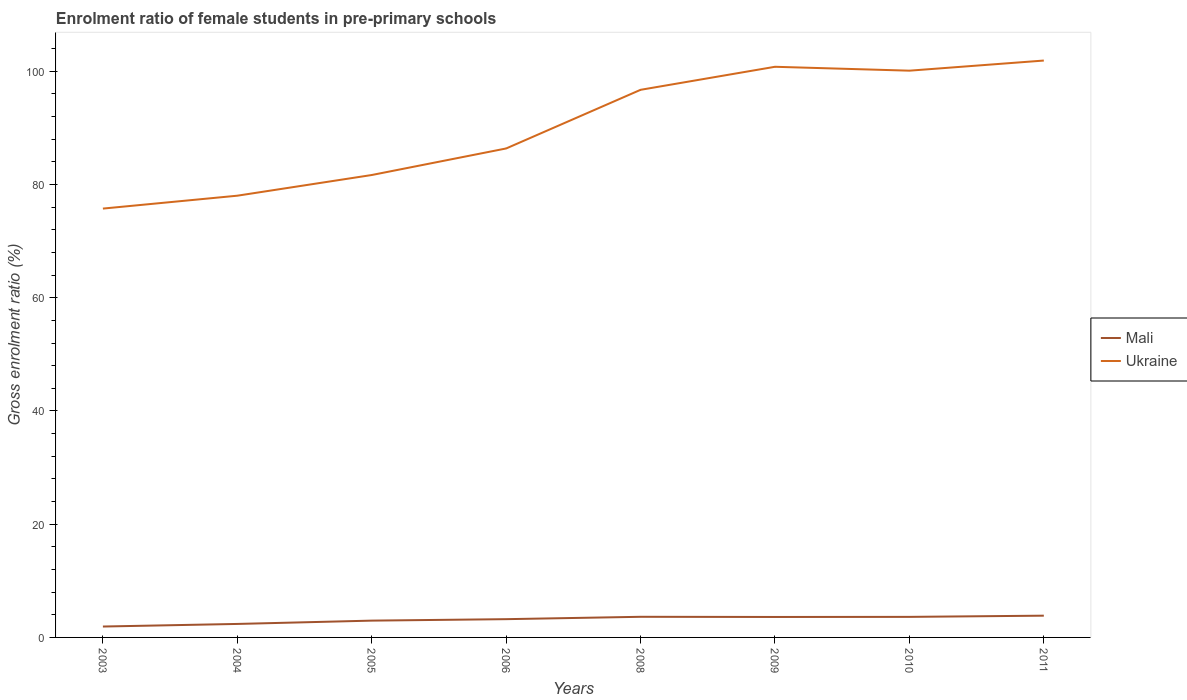How many different coloured lines are there?
Your answer should be compact. 2. Is the number of lines equal to the number of legend labels?
Give a very brief answer. Yes. Across all years, what is the maximum enrolment ratio of female students in pre-primary schools in Ukraine?
Keep it short and to the point. 75.74. What is the total enrolment ratio of female students in pre-primary schools in Ukraine in the graph?
Offer a very short reply. -15.05. What is the difference between the highest and the second highest enrolment ratio of female students in pre-primary schools in Mali?
Keep it short and to the point. 1.92. What is the difference between the highest and the lowest enrolment ratio of female students in pre-primary schools in Ukraine?
Offer a terse response. 4. Is the enrolment ratio of female students in pre-primary schools in Mali strictly greater than the enrolment ratio of female students in pre-primary schools in Ukraine over the years?
Offer a very short reply. Yes. How many years are there in the graph?
Offer a very short reply. 8. What is the difference between two consecutive major ticks on the Y-axis?
Your answer should be compact. 20. Does the graph contain grids?
Your response must be concise. No. Where does the legend appear in the graph?
Provide a short and direct response. Center right. How many legend labels are there?
Offer a very short reply. 2. What is the title of the graph?
Provide a short and direct response. Enrolment ratio of female students in pre-primary schools. Does "Fragile and conflict affected situations" appear as one of the legend labels in the graph?
Your response must be concise. No. What is the label or title of the X-axis?
Your answer should be compact. Years. What is the Gross enrolment ratio (%) in Mali in 2003?
Make the answer very short. 1.92. What is the Gross enrolment ratio (%) in Ukraine in 2003?
Provide a short and direct response. 75.74. What is the Gross enrolment ratio (%) of Mali in 2004?
Provide a succinct answer. 2.38. What is the Gross enrolment ratio (%) in Ukraine in 2004?
Provide a succinct answer. 78.02. What is the Gross enrolment ratio (%) of Mali in 2005?
Keep it short and to the point. 2.97. What is the Gross enrolment ratio (%) of Ukraine in 2005?
Provide a succinct answer. 81.67. What is the Gross enrolment ratio (%) in Mali in 2006?
Your response must be concise. 3.23. What is the Gross enrolment ratio (%) of Ukraine in 2006?
Make the answer very short. 86.36. What is the Gross enrolment ratio (%) of Mali in 2008?
Give a very brief answer. 3.64. What is the Gross enrolment ratio (%) of Ukraine in 2008?
Your answer should be very brief. 96.72. What is the Gross enrolment ratio (%) of Mali in 2009?
Provide a succinct answer. 3.61. What is the Gross enrolment ratio (%) in Ukraine in 2009?
Offer a terse response. 100.79. What is the Gross enrolment ratio (%) in Mali in 2010?
Your answer should be very brief. 3.63. What is the Gross enrolment ratio (%) of Ukraine in 2010?
Give a very brief answer. 100.1. What is the Gross enrolment ratio (%) of Mali in 2011?
Keep it short and to the point. 3.84. What is the Gross enrolment ratio (%) of Ukraine in 2011?
Offer a terse response. 101.89. Across all years, what is the maximum Gross enrolment ratio (%) in Mali?
Provide a succinct answer. 3.84. Across all years, what is the maximum Gross enrolment ratio (%) in Ukraine?
Offer a very short reply. 101.89. Across all years, what is the minimum Gross enrolment ratio (%) in Mali?
Provide a succinct answer. 1.92. Across all years, what is the minimum Gross enrolment ratio (%) in Ukraine?
Offer a terse response. 75.74. What is the total Gross enrolment ratio (%) in Mali in the graph?
Provide a short and direct response. 25.23. What is the total Gross enrolment ratio (%) of Ukraine in the graph?
Offer a terse response. 721.29. What is the difference between the Gross enrolment ratio (%) of Mali in 2003 and that in 2004?
Your answer should be compact. -0.46. What is the difference between the Gross enrolment ratio (%) of Ukraine in 2003 and that in 2004?
Provide a succinct answer. -2.28. What is the difference between the Gross enrolment ratio (%) in Mali in 2003 and that in 2005?
Give a very brief answer. -1.04. What is the difference between the Gross enrolment ratio (%) in Ukraine in 2003 and that in 2005?
Your answer should be very brief. -5.93. What is the difference between the Gross enrolment ratio (%) in Mali in 2003 and that in 2006?
Your answer should be very brief. -1.3. What is the difference between the Gross enrolment ratio (%) of Ukraine in 2003 and that in 2006?
Provide a short and direct response. -10.62. What is the difference between the Gross enrolment ratio (%) of Mali in 2003 and that in 2008?
Give a very brief answer. -1.72. What is the difference between the Gross enrolment ratio (%) of Ukraine in 2003 and that in 2008?
Provide a short and direct response. -20.98. What is the difference between the Gross enrolment ratio (%) of Mali in 2003 and that in 2009?
Offer a very short reply. -1.69. What is the difference between the Gross enrolment ratio (%) in Ukraine in 2003 and that in 2009?
Keep it short and to the point. -25.05. What is the difference between the Gross enrolment ratio (%) of Mali in 2003 and that in 2010?
Provide a short and direct response. -1.7. What is the difference between the Gross enrolment ratio (%) of Ukraine in 2003 and that in 2010?
Your answer should be compact. -24.36. What is the difference between the Gross enrolment ratio (%) of Mali in 2003 and that in 2011?
Offer a terse response. -1.92. What is the difference between the Gross enrolment ratio (%) in Ukraine in 2003 and that in 2011?
Provide a short and direct response. -26.15. What is the difference between the Gross enrolment ratio (%) of Mali in 2004 and that in 2005?
Make the answer very short. -0.58. What is the difference between the Gross enrolment ratio (%) of Ukraine in 2004 and that in 2005?
Your answer should be very brief. -3.65. What is the difference between the Gross enrolment ratio (%) in Mali in 2004 and that in 2006?
Offer a very short reply. -0.84. What is the difference between the Gross enrolment ratio (%) of Ukraine in 2004 and that in 2006?
Offer a terse response. -8.34. What is the difference between the Gross enrolment ratio (%) in Mali in 2004 and that in 2008?
Offer a terse response. -1.26. What is the difference between the Gross enrolment ratio (%) in Ukraine in 2004 and that in 2008?
Your answer should be very brief. -18.7. What is the difference between the Gross enrolment ratio (%) of Mali in 2004 and that in 2009?
Make the answer very short. -1.23. What is the difference between the Gross enrolment ratio (%) of Ukraine in 2004 and that in 2009?
Give a very brief answer. -22.77. What is the difference between the Gross enrolment ratio (%) in Mali in 2004 and that in 2010?
Provide a succinct answer. -1.25. What is the difference between the Gross enrolment ratio (%) of Ukraine in 2004 and that in 2010?
Your answer should be compact. -22.08. What is the difference between the Gross enrolment ratio (%) in Mali in 2004 and that in 2011?
Your answer should be compact. -1.46. What is the difference between the Gross enrolment ratio (%) in Ukraine in 2004 and that in 2011?
Provide a succinct answer. -23.87. What is the difference between the Gross enrolment ratio (%) in Mali in 2005 and that in 2006?
Offer a very short reply. -0.26. What is the difference between the Gross enrolment ratio (%) in Ukraine in 2005 and that in 2006?
Make the answer very short. -4.69. What is the difference between the Gross enrolment ratio (%) of Mali in 2005 and that in 2008?
Your answer should be compact. -0.68. What is the difference between the Gross enrolment ratio (%) in Ukraine in 2005 and that in 2008?
Ensure brevity in your answer.  -15.05. What is the difference between the Gross enrolment ratio (%) of Mali in 2005 and that in 2009?
Your answer should be compact. -0.65. What is the difference between the Gross enrolment ratio (%) in Ukraine in 2005 and that in 2009?
Your answer should be very brief. -19.12. What is the difference between the Gross enrolment ratio (%) of Mali in 2005 and that in 2010?
Keep it short and to the point. -0.66. What is the difference between the Gross enrolment ratio (%) in Ukraine in 2005 and that in 2010?
Your answer should be very brief. -18.43. What is the difference between the Gross enrolment ratio (%) of Mali in 2005 and that in 2011?
Ensure brevity in your answer.  -0.88. What is the difference between the Gross enrolment ratio (%) of Ukraine in 2005 and that in 2011?
Keep it short and to the point. -20.22. What is the difference between the Gross enrolment ratio (%) in Mali in 2006 and that in 2008?
Ensure brevity in your answer.  -0.42. What is the difference between the Gross enrolment ratio (%) in Ukraine in 2006 and that in 2008?
Provide a succinct answer. -10.36. What is the difference between the Gross enrolment ratio (%) in Mali in 2006 and that in 2009?
Give a very brief answer. -0.39. What is the difference between the Gross enrolment ratio (%) in Ukraine in 2006 and that in 2009?
Your answer should be compact. -14.43. What is the difference between the Gross enrolment ratio (%) in Mali in 2006 and that in 2010?
Make the answer very short. -0.4. What is the difference between the Gross enrolment ratio (%) of Ukraine in 2006 and that in 2010?
Your answer should be very brief. -13.74. What is the difference between the Gross enrolment ratio (%) of Mali in 2006 and that in 2011?
Your answer should be compact. -0.62. What is the difference between the Gross enrolment ratio (%) in Ukraine in 2006 and that in 2011?
Give a very brief answer. -15.53. What is the difference between the Gross enrolment ratio (%) of Mali in 2008 and that in 2009?
Your answer should be very brief. 0.03. What is the difference between the Gross enrolment ratio (%) in Ukraine in 2008 and that in 2009?
Offer a very short reply. -4.07. What is the difference between the Gross enrolment ratio (%) of Mali in 2008 and that in 2010?
Offer a very short reply. 0.02. What is the difference between the Gross enrolment ratio (%) of Ukraine in 2008 and that in 2010?
Ensure brevity in your answer.  -3.38. What is the difference between the Gross enrolment ratio (%) in Mali in 2008 and that in 2011?
Give a very brief answer. -0.2. What is the difference between the Gross enrolment ratio (%) of Ukraine in 2008 and that in 2011?
Give a very brief answer. -5.17. What is the difference between the Gross enrolment ratio (%) of Mali in 2009 and that in 2010?
Offer a terse response. -0.01. What is the difference between the Gross enrolment ratio (%) in Ukraine in 2009 and that in 2010?
Keep it short and to the point. 0.69. What is the difference between the Gross enrolment ratio (%) of Mali in 2009 and that in 2011?
Your answer should be compact. -0.23. What is the difference between the Gross enrolment ratio (%) of Ukraine in 2009 and that in 2011?
Offer a terse response. -1.1. What is the difference between the Gross enrolment ratio (%) of Mali in 2010 and that in 2011?
Make the answer very short. -0.21. What is the difference between the Gross enrolment ratio (%) in Ukraine in 2010 and that in 2011?
Offer a terse response. -1.79. What is the difference between the Gross enrolment ratio (%) in Mali in 2003 and the Gross enrolment ratio (%) in Ukraine in 2004?
Offer a very short reply. -76.09. What is the difference between the Gross enrolment ratio (%) in Mali in 2003 and the Gross enrolment ratio (%) in Ukraine in 2005?
Give a very brief answer. -79.75. What is the difference between the Gross enrolment ratio (%) of Mali in 2003 and the Gross enrolment ratio (%) of Ukraine in 2006?
Your response must be concise. -84.44. What is the difference between the Gross enrolment ratio (%) in Mali in 2003 and the Gross enrolment ratio (%) in Ukraine in 2008?
Give a very brief answer. -94.8. What is the difference between the Gross enrolment ratio (%) in Mali in 2003 and the Gross enrolment ratio (%) in Ukraine in 2009?
Provide a succinct answer. -98.86. What is the difference between the Gross enrolment ratio (%) of Mali in 2003 and the Gross enrolment ratio (%) of Ukraine in 2010?
Your answer should be very brief. -98.17. What is the difference between the Gross enrolment ratio (%) in Mali in 2003 and the Gross enrolment ratio (%) in Ukraine in 2011?
Provide a short and direct response. -99.96. What is the difference between the Gross enrolment ratio (%) of Mali in 2004 and the Gross enrolment ratio (%) of Ukraine in 2005?
Your answer should be very brief. -79.29. What is the difference between the Gross enrolment ratio (%) in Mali in 2004 and the Gross enrolment ratio (%) in Ukraine in 2006?
Offer a very short reply. -83.98. What is the difference between the Gross enrolment ratio (%) in Mali in 2004 and the Gross enrolment ratio (%) in Ukraine in 2008?
Your response must be concise. -94.34. What is the difference between the Gross enrolment ratio (%) of Mali in 2004 and the Gross enrolment ratio (%) of Ukraine in 2009?
Offer a terse response. -98.4. What is the difference between the Gross enrolment ratio (%) of Mali in 2004 and the Gross enrolment ratio (%) of Ukraine in 2010?
Provide a succinct answer. -97.72. What is the difference between the Gross enrolment ratio (%) of Mali in 2004 and the Gross enrolment ratio (%) of Ukraine in 2011?
Make the answer very short. -99.51. What is the difference between the Gross enrolment ratio (%) in Mali in 2005 and the Gross enrolment ratio (%) in Ukraine in 2006?
Provide a succinct answer. -83.39. What is the difference between the Gross enrolment ratio (%) of Mali in 2005 and the Gross enrolment ratio (%) of Ukraine in 2008?
Give a very brief answer. -93.75. What is the difference between the Gross enrolment ratio (%) in Mali in 2005 and the Gross enrolment ratio (%) in Ukraine in 2009?
Provide a short and direct response. -97.82. What is the difference between the Gross enrolment ratio (%) of Mali in 2005 and the Gross enrolment ratio (%) of Ukraine in 2010?
Provide a short and direct response. -97.13. What is the difference between the Gross enrolment ratio (%) of Mali in 2005 and the Gross enrolment ratio (%) of Ukraine in 2011?
Offer a terse response. -98.92. What is the difference between the Gross enrolment ratio (%) of Mali in 2006 and the Gross enrolment ratio (%) of Ukraine in 2008?
Make the answer very short. -93.49. What is the difference between the Gross enrolment ratio (%) of Mali in 2006 and the Gross enrolment ratio (%) of Ukraine in 2009?
Provide a short and direct response. -97.56. What is the difference between the Gross enrolment ratio (%) of Mali in 2006 and the Gross enrolment ratio (%) of Ukraine in 2010?
Make the answer very short. -96.87. What is the difference between the Gross enrolment ratio (%) in Mali in 2006 and the Gross enrolment ratio (%) in Ukraine in 2011?
Ensure brevity in your answer.  -98.66. What is the difference between the Gross enrolment ratio (%) in Mali in 2008 and the Gross enrolment ratio (%) in Ukraine in 2009?
Provide a succinct answer. -97.14. What is the difference between the Gross enrolment ratio (%) of Mali in 2008 and the Gross enrolment ratio (%) of Ukraine in 2010?
Offer a terse response. -96.45. What is the difference between the Gross enrolment ratio (%) of Mali in 2008 and the Gross enrolment ratio (%) of Ukraine in 2011?
Your response must be concise. -98.24. What is the difference between the Gross enrolment ratio (%) of Mali in 2009 and the Gross enrolment ratio (%) of Ukraine in 2010?
Your answer should be compact. -96.48. What is the difference between the Gross enrolment ratio (%) in Mali in 2009 and the Gross enrolment ratio (%) in Ukraine in 2011?
Make the answer very short. -98.27. What is the difference between the Gross enrolment ratio (%) in Mali in 2010 and the Gross enrolment ratio (%) in Ukraine in 2011?
Make the answer very short. -98.26. What is the average Gross enrolment ratio (%) of Mali per year?
Your answer should be compact. 3.15. What is the average Gross enrolment ratio (%) in Ukraine per year?
Keep it short and to the point. 90.16. In the year 2003, what is the difference between the Gross enrolment ratio (%) in Mali and Gross enrolment ratio (%) in Ukraine?
Make the answer very short. -73.82. In the year 2004, what is the difference between the Gross enrolment ratio (%) in Mali and Gross enrolment ratio (%) in Ukraine?
Give a very brief answer. -75.64. In the year 2005, what is the difference between the Gross enrolment ratio (%) of Mali and Gross enrolment ratio (%) of Ukraine?
Keep it short and to the point. -78.7. In the year 2006, what is the difference between the Gross enrolment ratio (%) in Mali and Gross enrolment ratio (%) in Ukraine?
Offer a terse response. -83.14. In the year 2008, what is the difference between the Gross enrolment ratio (%) in Mali and Gross enrolment ratio (%) in Ukraine?
Offer a very short reply. -93.08. In the year 2009, what is the difference between the Gross enrolment ratio (%) of Mali and Gross enrolment ratio (%) of Ukraine?
Offer a very short reply. -97.17. In the year 2010, what is the difference between the Gross enrolment ratio (%) in Mali and Gross enrolment ratio (%) in Ukraine?
Ensure brevity in your answer.  -96.47. In the year 2011, what is the difference between the Gross enrolment ratio (%) of Mali and Gross enrolment ratio (%) of Ukraine?
Give a very brief answer. -98.05. What is the ratio of the Gross enrolment ratio (%) of Mali in 2003 to that in 2004?
Your answer should be compact. 0.81. What is the ratio of the Gross enrolment ratio (%) in Ukraine in 2003 to that in 2004?
Your response must be concise. 0.97. What is the ratio of the Gross enrolment ratio (%) in Mali in 2003 to that in 2005?
Give a very brief answer. 0.65. What is the ratio of the Gross enrolment ratio (%) in Ukraine in 2003 to that in 2005?
Keep it short and to the point. 0.93. What is the ratio of the Gross enrolment ratio (%) of Mali in 2003 to that in 2006?
Give a very brief answer. 0.6. What is the ratio of the Gross enrolment ratio (%) of Ukraine in 2003 to that in 2006?
Keep it short and to the point. 0.88. What is the ratio of the Gross enrolment ratio (%) of Mali in 2003 to that in 2008?
Your response must be concise. 0.53. What is the ratio of the Gross enrolment ratio (%) of Ukraine in 2003 to that in 2008?
Provide a succinct answer. 0.78. What is the ratio of the Gross enrolment ratio (%) of Mali in 2003 to that in 2009?
Ensure brevity in your answer.  0.53. What is the ratio of the Gross enrolment ratio (%) in Ukraine in 2003 to that in 2009?
Your answer should be very brief. 0.75. What is the ratio of the Gross enrolment ratio (%) of Mali in 2003 to that in 2010?
Keep it short and to the point. 0.53. What is the ratio of the Gross enrolment ratio (%) in Ukraine in 2003 to that in 2010?
Ensure brevity in your answer.  0.76. What is the ratio of the Gross enrolment ratio (%) of Mali in 2003 to that in 2011?
Provide a succinct answer. 0.5. What is the ratio of the Gross enrolment ratio (%) in Ukraine in 2003 to that in 2011?
Your response must be concise. 0.74. What is the ratio of the Gross enrolment ratio (%) of Mali in 2004 to that in 2005?
Offer a terse response. 0.8. What is the ratio of the Gross enrolment ratio (%) of Ukraine in 2004 to that in 2005?
Offer a terse response. 0.96. What is the ratio of the Gross enrolment ratio (%) of Mali in 2004 to that in 2006?
Your response must be concise. 0.74. What is the ratio of the Gross enrolment ratio (%) of Ukraine in 2004 to that in 2006?
Give a very brief answer. 0.9. What is the ratio of the Gross enrolment ratio (%) in Mali in 2004 to that in 2008?
Provide a succinct answer. 0.65. What is the ratio of the Gross enrolment ratio (%) in Ukraine in 2004 to that in 2008?
Provide a succinct answer. 0.81. What is the ratio of the Gross enrolment ratio (%) in Mali in 2004 to that in 2009?
Make the answer very short. 0.66. What is the ratio of the Gross enrolment ratio (%) in Ukraine in 2004 to that in 2009?
Your response must be concise. 0.77. What is the ratio of the Gross enrolment ratio (%) in Mali in 2004 to that in 2010?
Give a very brief answer. 0.66. What is the ratio of the Gross enrolment ratio (%) of Ukraine in 2004 to that in 2010?
Your answer should be very brief. 0.78. What is the ratio of the Gross enrolment ratio (%) of Mali in 2004 to that in 2011?
Make the answer very short. 0.62. What is the ratio of the Gross enrolment ratio (%) in Ukraine in 2004 to that in 2011?
Give a very brief answer. 0.77. What is the ratio of the Gross enrolment ratio (%) in Mali in 2005 to that in 2006?
Your answer should be very brief. 0.92. What is the ratio of the Gross enrolment ratio (%) of Ukraine in 2005 to that in 2006?
Offer a terse response. 0.95. What is the ratio of the Gross enrolment ratio (%) of Mali in 2005 to that in 2008?
Offer a very short reply. 0.81. What is the ratio of the Gross enrolment ratio (%) of Ukraine in 2005 to that in 2008?
Make the answer very short. 0.84. What is the ratio of the Gross enrolment ratio (%) of Mali in 2005 to that in 2009?
Provide a short and direct response. 0.82. What is the ratio of the Gross enrolment ratio (%) in Ukraine in 2005 to that in 2009?
Your answer should be compact. 0.81. What is the ratio of the Gross enrolment ratio (%) in Mali in 2005 to that in 2010?
Make the answer very short. 0.82. What is the ratio of the Gross enrolment ratio (%) of Ukraine in 2005 to that in 2010?
Your response must be concise. 0.82. What is the ratio of the Gross enrolment ratio (%) in Mali in 2005 to that in 2011?
Your answer should be compact. 0.77. What is the ratio of the Gross enrolment ratio (%) of Ukraine in 2005 to that in 2011?
Provide a succinct answer. 0.8. What is the ratio of the Gross enrolment ratio (%) in Mali in 2006 to that in 2008?
Your response must be concise. 0.89. What is the ratio of the Gross enrolment ratio (%) in Ukraine in 2006 to that in 2008?
Offer a very short reply. 0.89. What is the ratio of the Gross enrolment ratio (%) in Mali in 2006 to that in 2009?
Give a very brief answer. 0.89. What is the ratio of the Gross enrolment ratio (%) in Ukraine in 2006 to that in 2009?
Ensure brevity in your answer.  0.86. What is the ratio of the Gross enrolment ratio (%) of Mali in 2006 to that in 2010?
Provide a succinct answer. 0.89. What is the ratio of the Gross enrolment ratio (%) of Ukraine in 2006 to that in 2010?
Ensure brevity in your answer.  0.86. What is the ratio of the Gross enrolment ratio (%) of Mali in 2006 to that in 2011?
Ensure brevity in your answer.  0.84. What is the ratio of the Gross enrolment ratio (%) of Ukraine in 2006 to that in 2011?
Offer a terse response. 0.85. What is the ratio of the Gross enrolment ratio (%) in Mali in 2008 to that in 2009?
Your answer should be very brief. 1.01. What is the ratio of the Gross enrolment ratio (%) in Ukraine in 2008 to that in 2009?
Your response must be concise. 0.96. What is the ratio of the Gross enrolment ratio (%) in Ukraine in 2008 to that in 2010?
Offer a terse response. 0.97. What is the ratio of the Gross enrolment ratio (%) in Mali in 2008 to that in 2011?
Provide a short and direct response. 0.95. What is the ratio of the Gross enrolment ratio (%) of Ukraine in 2008 to that in 2011?
Your answer should be compact. 0.95. What is the ratio of the Gross enrolment ratio (%) in Mali in 2009 to that in 2010?
Ensure brevity in your answer.  1. What is the ratio of the Gross enrolment ratio (%) of Mali in 2009 to that in 2011?
Your response must be concise. 0.94. What is the ratio of the Gross enrolment ratio (%) in Ukraine in 2009 to that in 2011?
Offer a very short reply. 0.99. What is the ratio of the Gross enrolment ratio (%) in Mali in 2010 to that in 2011?
Offer a terse response. 0.94. What is the ratio of the Gross enrolment ratio (%) of Ukraine in 2010 to that in 2011?
Your response must be concise. 0.98. What is the difference between the highest and the second highest Gross enrolment ratio (%) in Mali?
Offer a terse response. 0.2. What is the difference between the highest and the second highest Gross enrolment ratio (%) in Ukraine?
Offer a terse response. 1.1. What is the difference between the highest and the lowest Gross enrolment ratio (%) in Mali?
Your answer should be compact. 1.92. What is the difference between the highest and the lowest Gross enrolment ratio (%) of Ukraine?
Your answer should be compact. 26.15. 